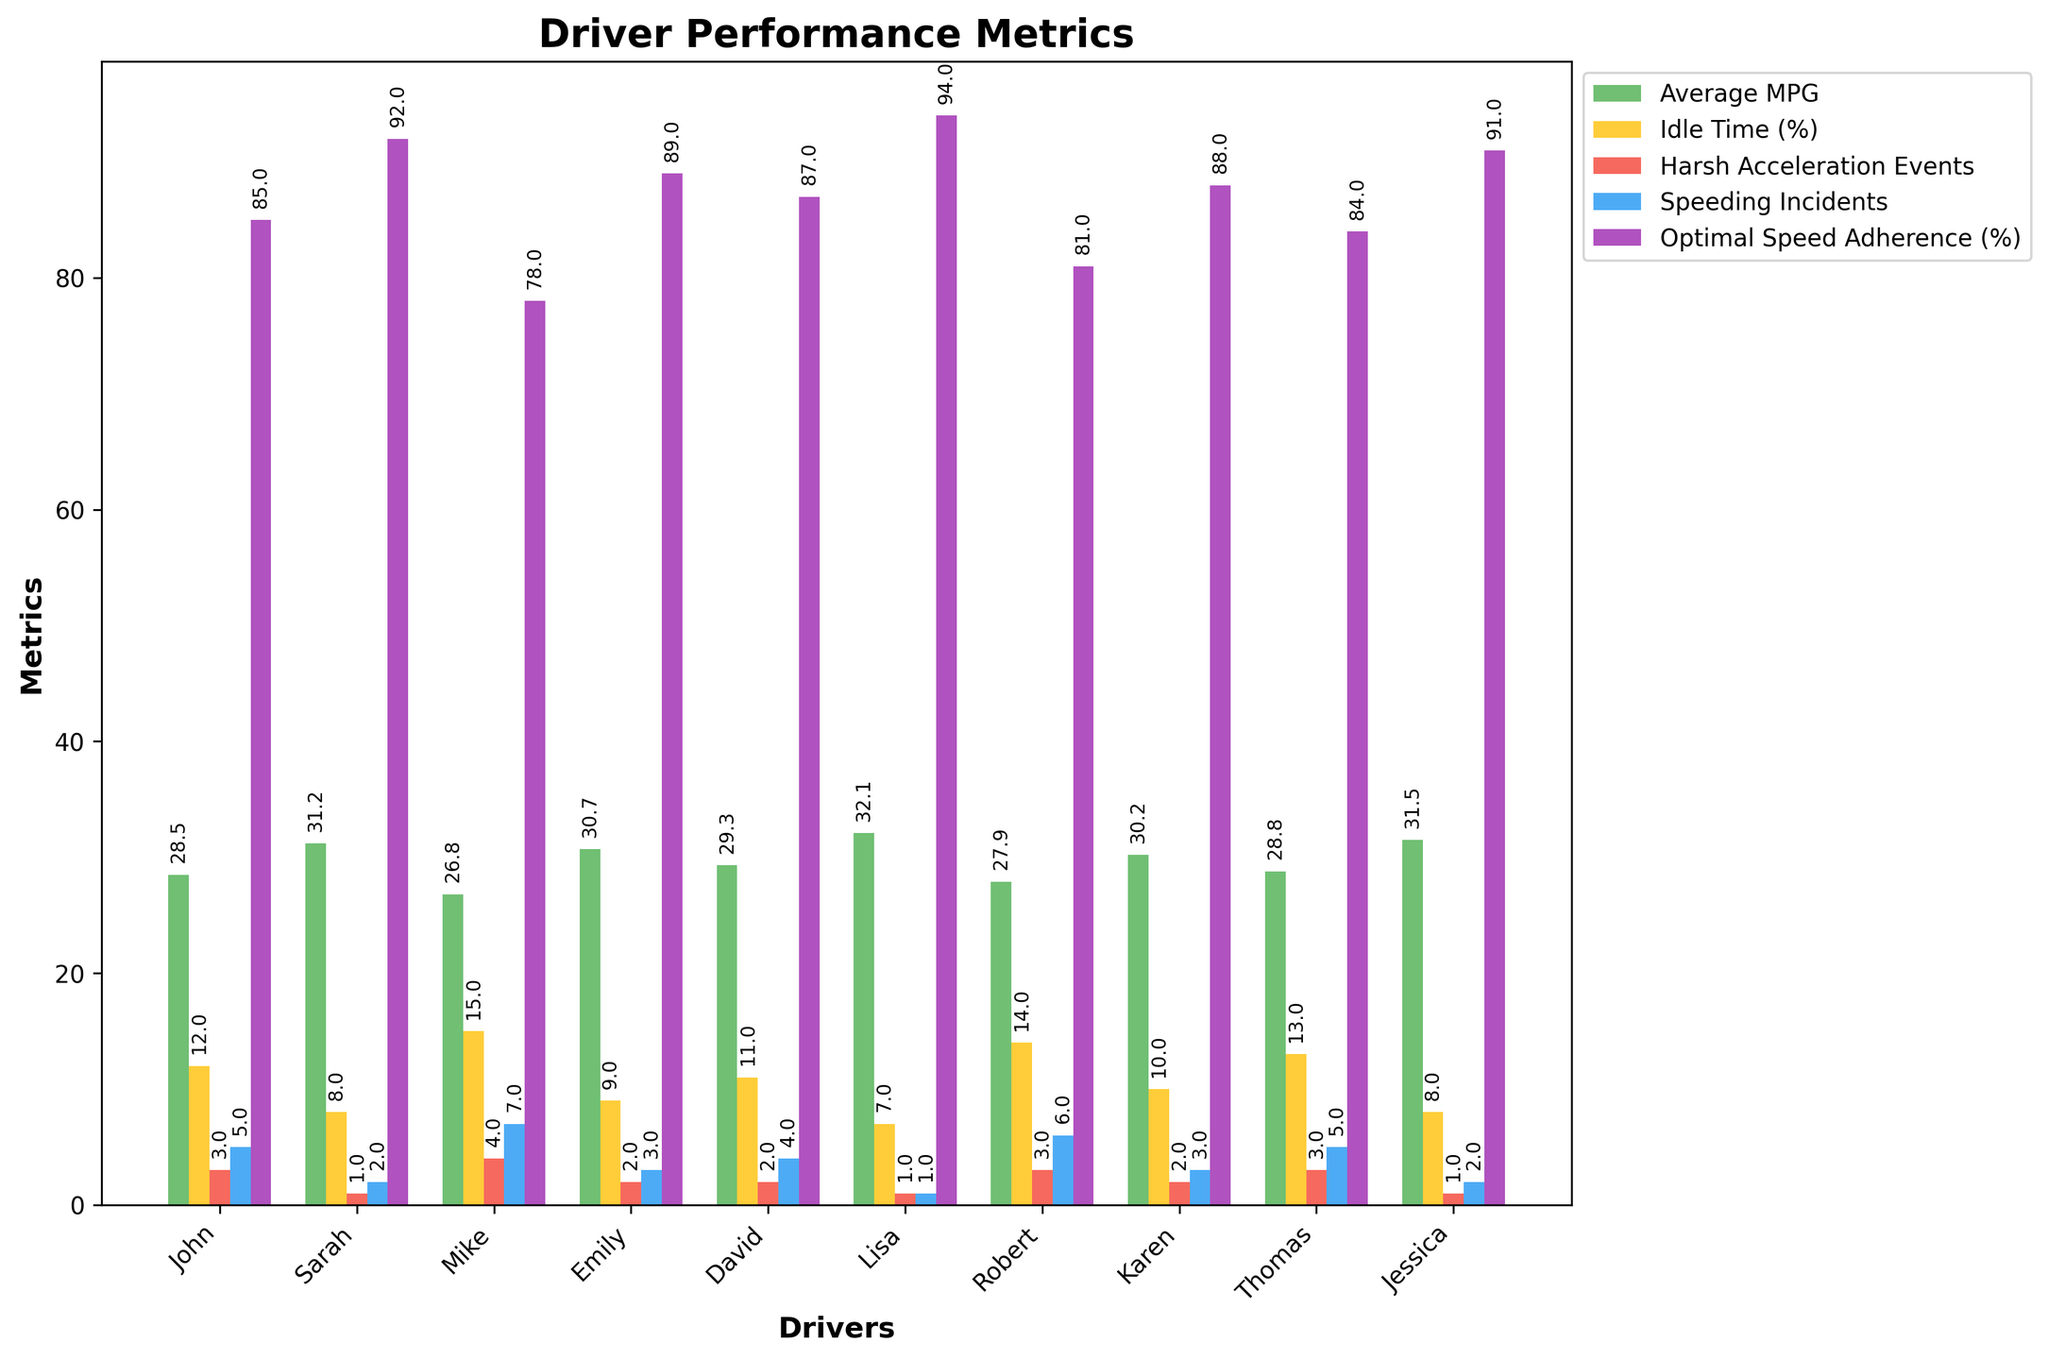Which driver has the highest Average MPG? To determine the driver with the highest Average MPG, look at the bars representing Average MPG for each driver and identify the tallest one. Lisa has the tallest bar for Average MPG.
Answer: Lisa Which driver has the most Speeding Incidents? Look at the bars representing Speeding Incidents for each driver and identify the driver with the highest bar. Mike has the highest bar for Speeding Incidents.
Answer: Mike What is the difference in Average MPG between Sarah and Robert? Locate Sarah's and Robert's bars for Average MPG. Sarah’s MPG is 31.2, and Robert’s is 27.9. Subtract Robert’s MPG from Sarah’s. 31.2 - 27.9 = 3.3
Answer: 3.3 Which driver has the least amount of Idle Time? Identify which driver has the shortest bar in the Idle Time (%) category. Lisa has the shortest bar for Idle Time.
Answer: Lisa What is the combined total of Harsh Acceleration Events for Emily and Jessica? Locate Emily's and Jessica's bars for Harsh Acceleration Events. Emily has 2 events, and Jessica has 1 event. Add these numbers together. 2 + 1 = 3
Answer: 3 Which driver adheres the most to Optimal Speed Adherence? Find which driver has the tallest bar in the Optimal Speed Adherence (%) category. Lisa has the tallest bar for Optimal Speed Adherence.
Answer: Lisa How many more Speeding Incidents does John have compared to Emily? Locate John’s and Emily's bars for Speeding Incidents. John has 5 and Emily has 3. Calculate the difference. 5 - 3 = 2
Answer: 2 What is the average Idle Time (%) across all drivers? Sum all the Idle Time (%) values (12 + 8 + 15 + 9 + 11 + 7 + 14 + 10 + 13 + 8 = 107) and divide by the number of drivers (10). 107 / 10 = 10.7
Answer: 10.7 Which driver has better Average MPG, Thomas or Karen? Compare the Average MPG bars for Thomas and Karen. Thomas has 28.8 MPG and Karen has 30.2 MPG. Karen has higher MPG.
Answer: Karen What is the sum of total Average MPG for all drivers whose Average MPG is above 30? Identify drivers with MPG above 30: Sarah (31.2), Emily (30.7), Lisa (32.1), and Jessica (31.5). Sum the values: 31.2 + 30.7 + 32.1 + 31.5 = 125.5
Answer: 125.5 